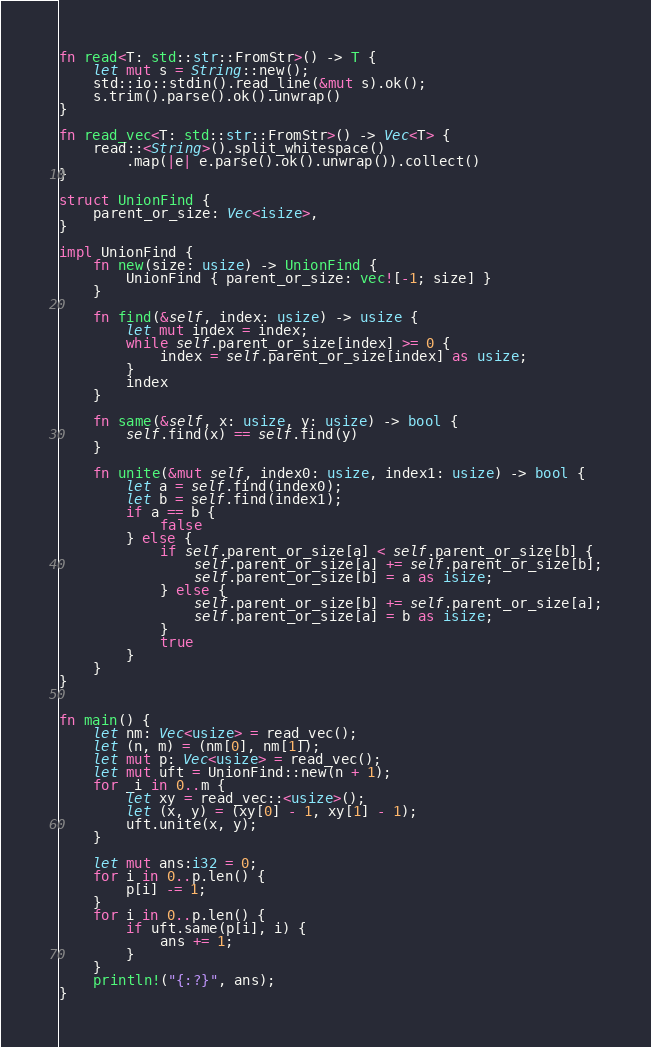Convert code to text. <code><loc_0><loc_0><loc_500><loc_500><_Rust_>fn read<T: std::str::FromStr>() -> T {
    let mut s = String::new();
    std::io::stdin().read_line(&mut s).ok();
    s.trim().parse().ok().unwrap()
}

fn read_vec<T: std::str::FromStr>() -> Vec<T> {
    read::<String>().split_whitespace()
        .map(|e| e.parse().ok().unwrap()).collect()
}

struct UnionFind {
    parent_or_size: Vec<isize>,
}

impl UnionFind {
    fn new(size: usize) -> UnionFind {
        UnionFind { parent_or_size: vec![-1; size] }
    }

    fn find(&self, index: usize) -> usize {
        let mut index = index;
        while self.parent_or_size[index] >= 0 {
            index = self.parent_or_size[index] as usize;
        }
        index
    }

    fn same(&self, x: usize, y: usize) -> bool {
        self.find(x) == self.find(y)
    }

    fn unite(&mut self, index0: usize, index1: usize) -> bool {
        let a = self.find(index0);
        let b = self.find(index1);
        if a == b {
            false
        } else {
            if self.parent_or_size[a] < self.parent_or_size[b] {
                self.parent_or_size[a] += self.parent_or_size[b];
                self.parent_or_size[b] = a as isize;
            } else {
                self.parent_or_size[b] += self.parent_or_size[a];
                self.parent_or_size[a] = b as isize;
            }
            true
        }
    }
}


fn main() {
    let nm: Vec<usize> = read_vec();
    let (n, m) = (nm[0], nm[1]);
    let mut p: Vec<usize> = read_vec();
    let mut uft = UnionFind::new(n + 1);
    for _i in 0..m {
        let xy = read_vec::<usize>();
        let (x, y) = (xy[0] - 1, xy[1] - 1);
        uft.unite(x, y);
    }

    let mut ans:i32 = 0;
    for i in 0..p.len() {
        p[i] -= 1;
    }
    for i in 0..p.len() {
        if uft.same(p[i], i) {
            ans += 1;
        }
    }
    println!("{:?}", ans);
}
</code> 